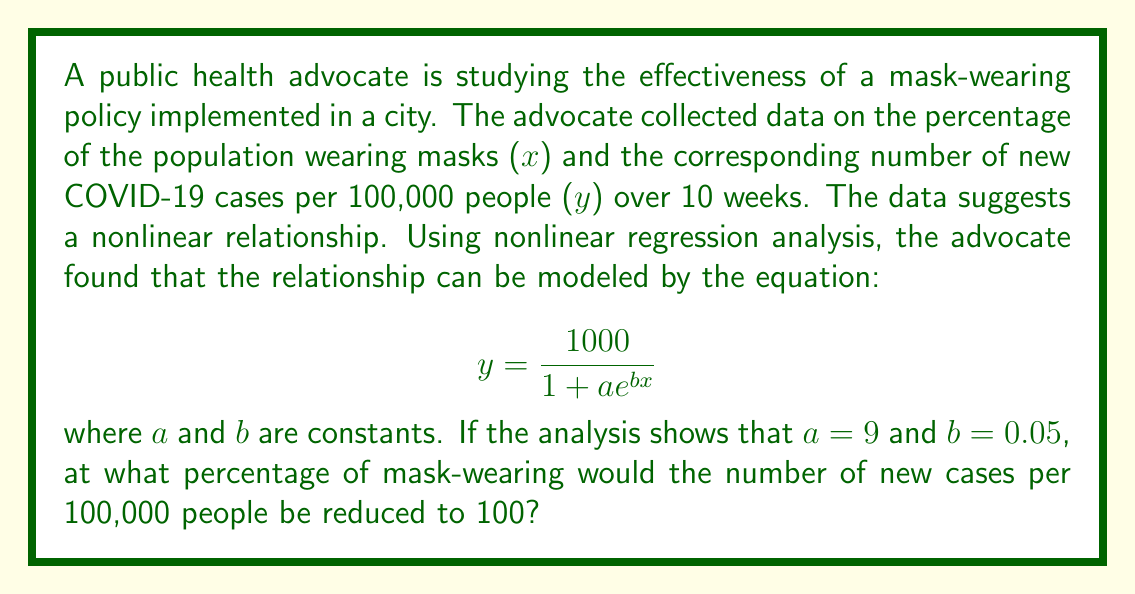Teach me how to tackle this problem. Let's approach this step-by-step:

1) We're given the nonlinear regression model:
   $$ y = \frac{1000}{1 + ae^{bx}} $$

2) We're also given that a = 9 and b = 0.05.

3) We want to find x when y = 100. Let's substitute these values:

   $$ 100 = \frac{1000}{1 + 9e^{0.05x}} $$

4) Now, let's solve for x:
   
   $$ 100(1 + 9e^{0.05x}) = 1000 $$
   $$ 100 + 900e^{0.05x} = 1000 $$
   $$ 900e^{0.05x} = 900 $$
   $$ e^{0.05x} = 1 $$

5) Taking the natural log of both sides:

   $$ \ln(e^{0.05x}) = \ln(1) $$
   $$ 0.05x = 0 $$

6) Solving for x:

   $$ x = \frac{0}{0.05} = 0 $$

Therefore, the model suggests that when 0% of the population is wearing masks, the number of new cases would be 100 per 100,000 people.

However, this result doesn't make practical sense in the context of the problem. The model likely breaks down at extreme values and shouldn't be extrapolated beyond the range of the collected data. In reality, we would expect higher case numbers with 0% mask-wearing.
Answer: 0% (with caveat that model may not be valid at extreme values) 